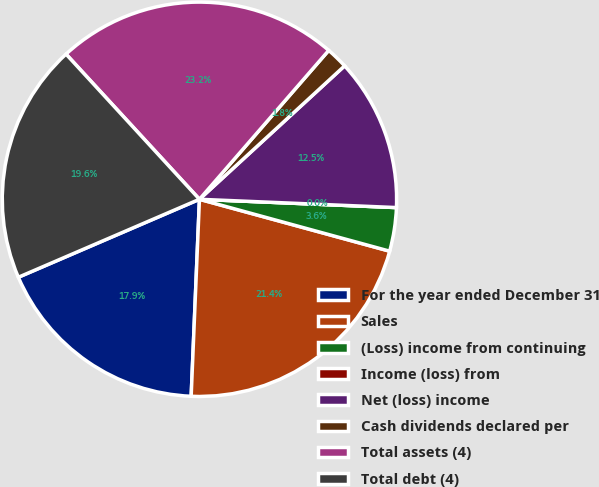<chart> <loc_0><loc_0><loc_500><loc_500><pie_chart><fcel>For the year ended December 31<fcel>Sales<fcel>(Loss) income from continuing<fcel>Income (loss) from<fcel>Net (loss) income<fcel>Cash dividends declared per<fcel>Total assets (4)<fcel>Total debt (4)<nl><fcel>17.86%<fcel>21.43%<fcel>3.57%<fcel>0.0%<fcel>12.5%<fcel>1.79%<fcel>23.21%<fcel>19.64%<nl></chart> 